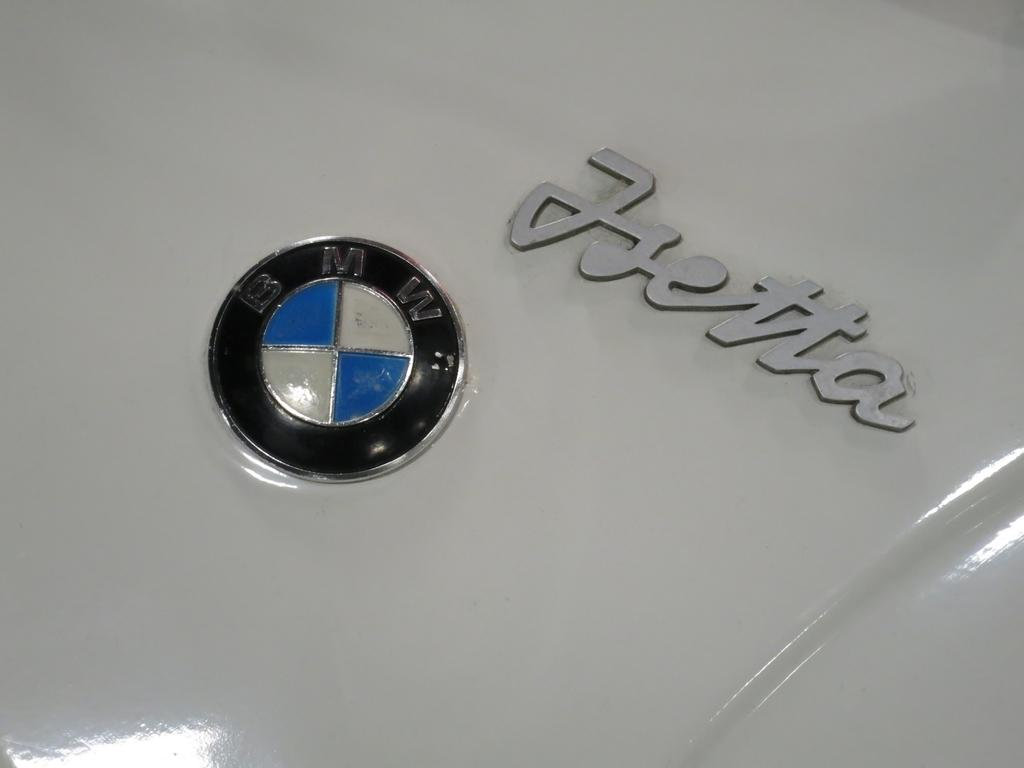What is the main subject of the image? The main subject of the image is a car bonnet. Are there any distinguishing features on the car bonnet? Yes, there is an emblem and text on the car bonnet. How many spiders are crawling on the wood in the image? There is no wood or spiders present in the image; it features a car bonnet with an emblem and text. 